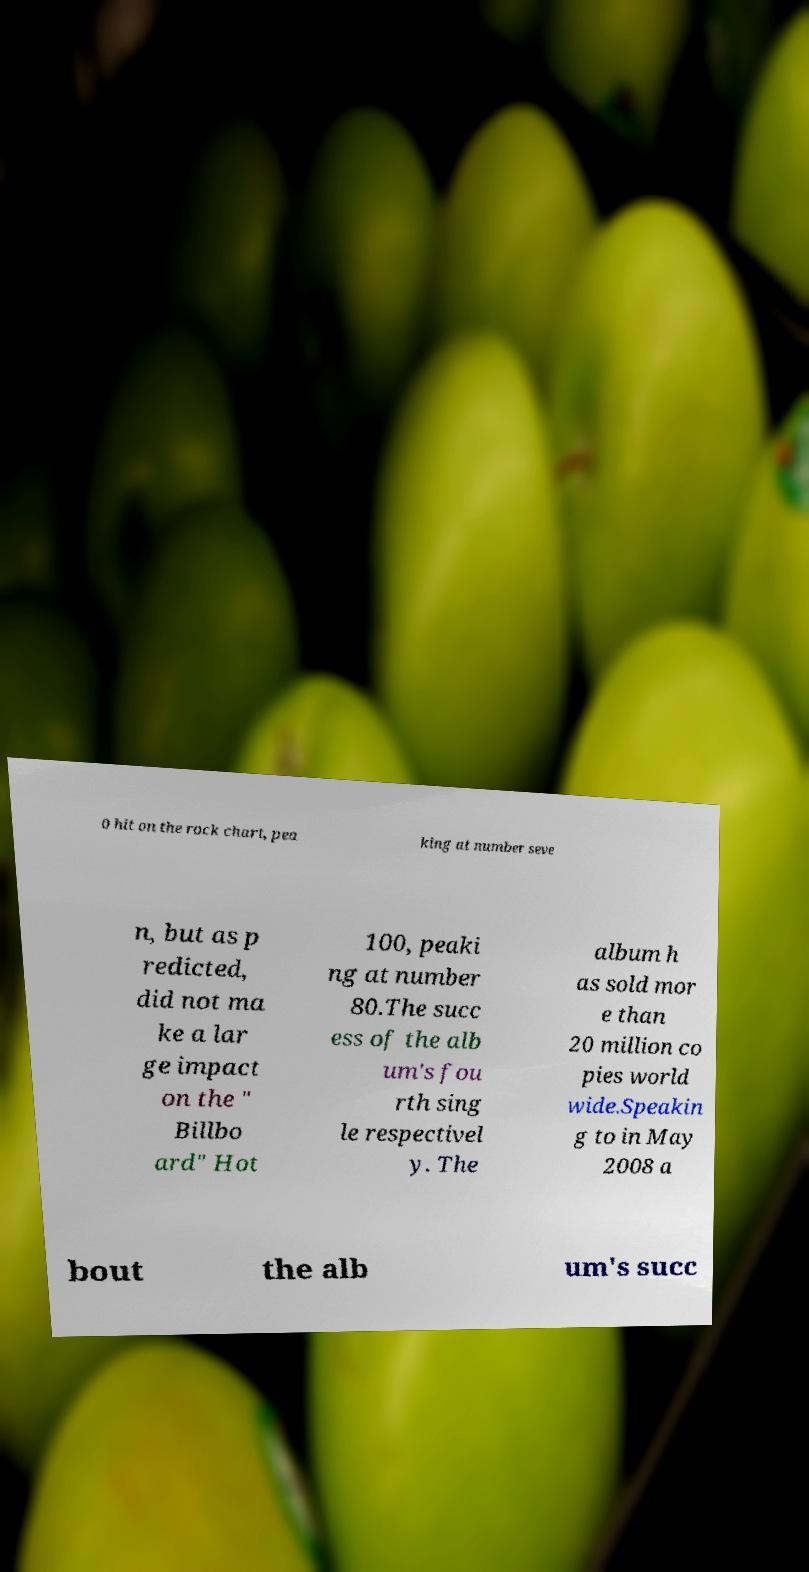Can you read and provide the text displayed in the image?This photo seems to have some interesting text. Can you extract and type it out for me? 0 hit on the rock chart, pea king at number seve n, but as p redicted, did not ma ke a lar ge impact on the " Billbo ard" Hot 100, peaki ng at number 80.The succ ess of the alb um's fou rth sing le respectivel y. The album h as sold mor e than 20 million co pies world wide.Speakin g to in May 2008 a bout the alb um's succ 